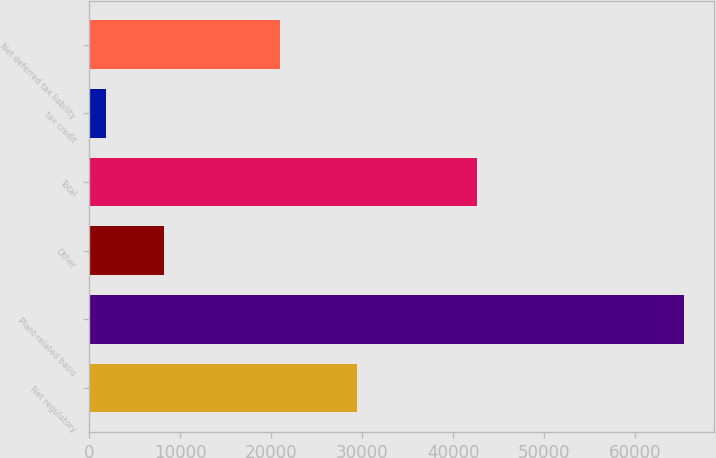Convert chart to OTSL. <chart><loc_0><loc_0><loc_500><loc_500><bar_chart><fcel>Net regulatory<fcel>Plant-related basis<fcel>Other<fcel>Total<fcel>tax credit<fcel>Net deferred tax liability<nl><fcel>29435<fcel>65357<fcel>8230.4<fcel>42575<fcel>1883<fcel>21015<nl></chart> 